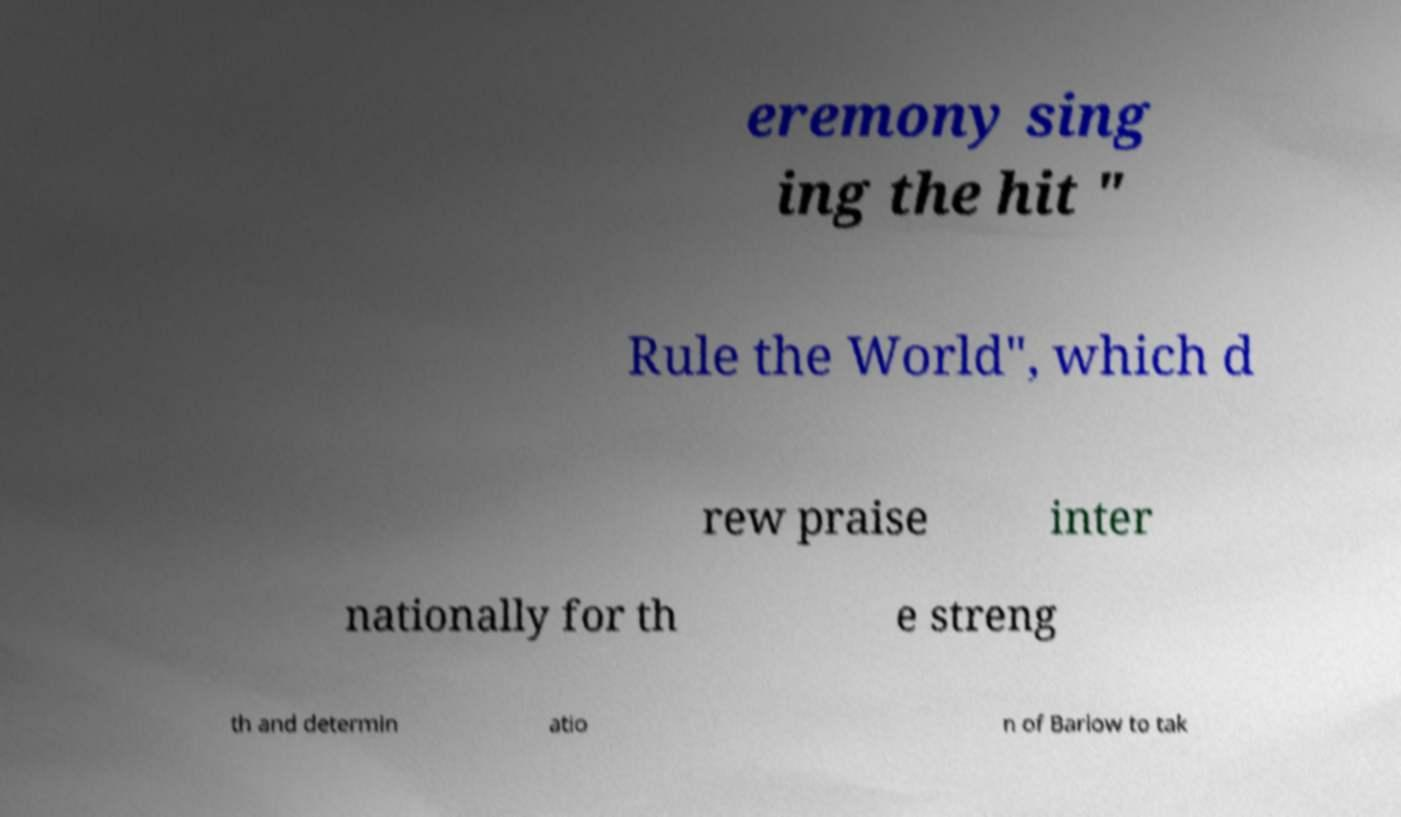Please read and relay the text visible in this image. What does it say? eremony sing ing the hit " Rule the World", which d rew praise inter nationally for th e streng th and determin atio n of Barlow to tak 